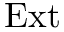Convert formula to latex. <formula><loc_0><loc_0><loc_500><loc_500>E x t</formula> 